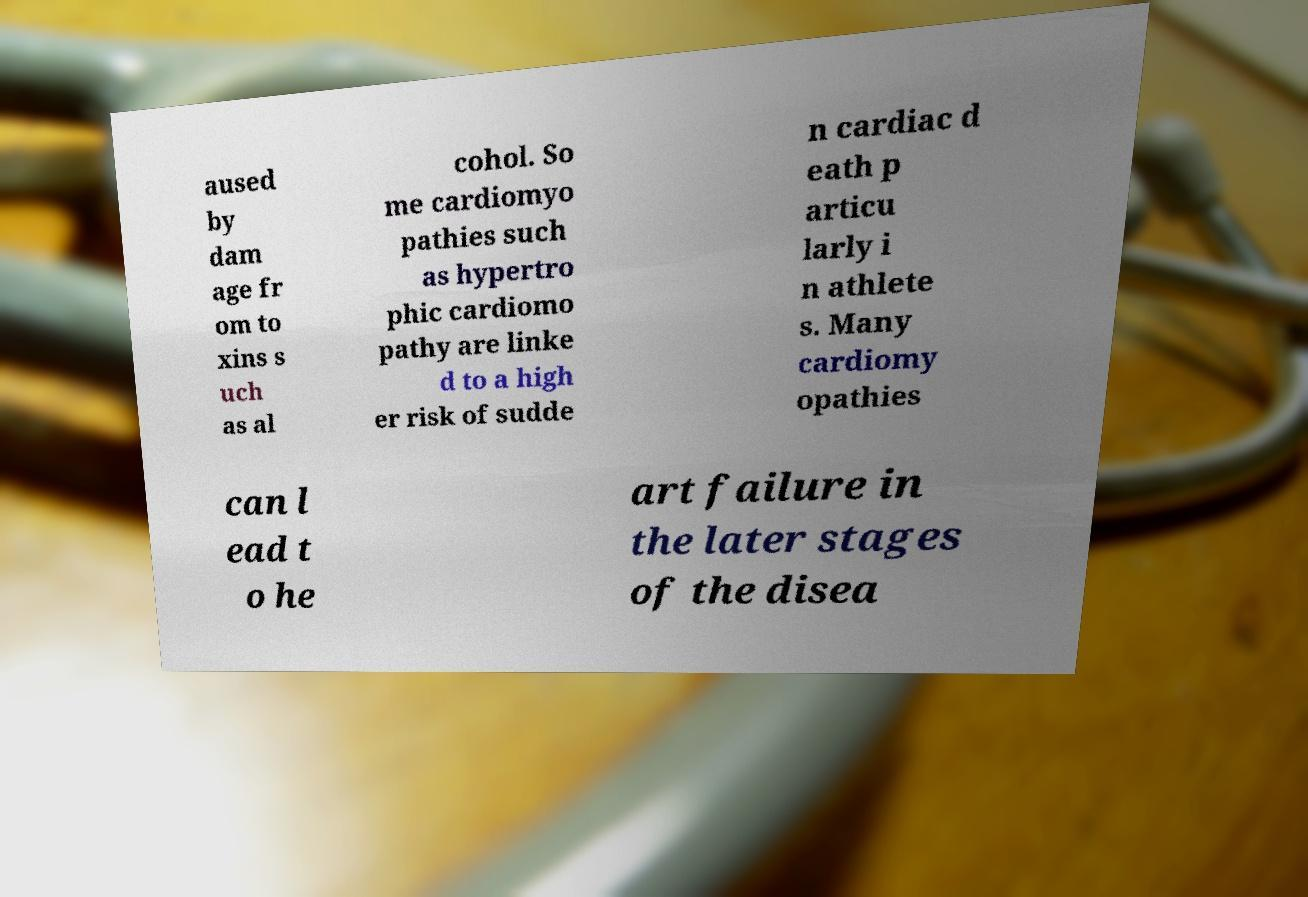Could you extract and type out the text from this image? aused by dam age fr om to xins s uch as al cohol. So me cardiomyo pathies such as hypertro phic cardiomo pathy are linke d to a high er risk of sudde n cardiac d eath p articu larly i n athlete s. Many cardiomy opathies can l ead t o he art failure in the later stages of the disea 